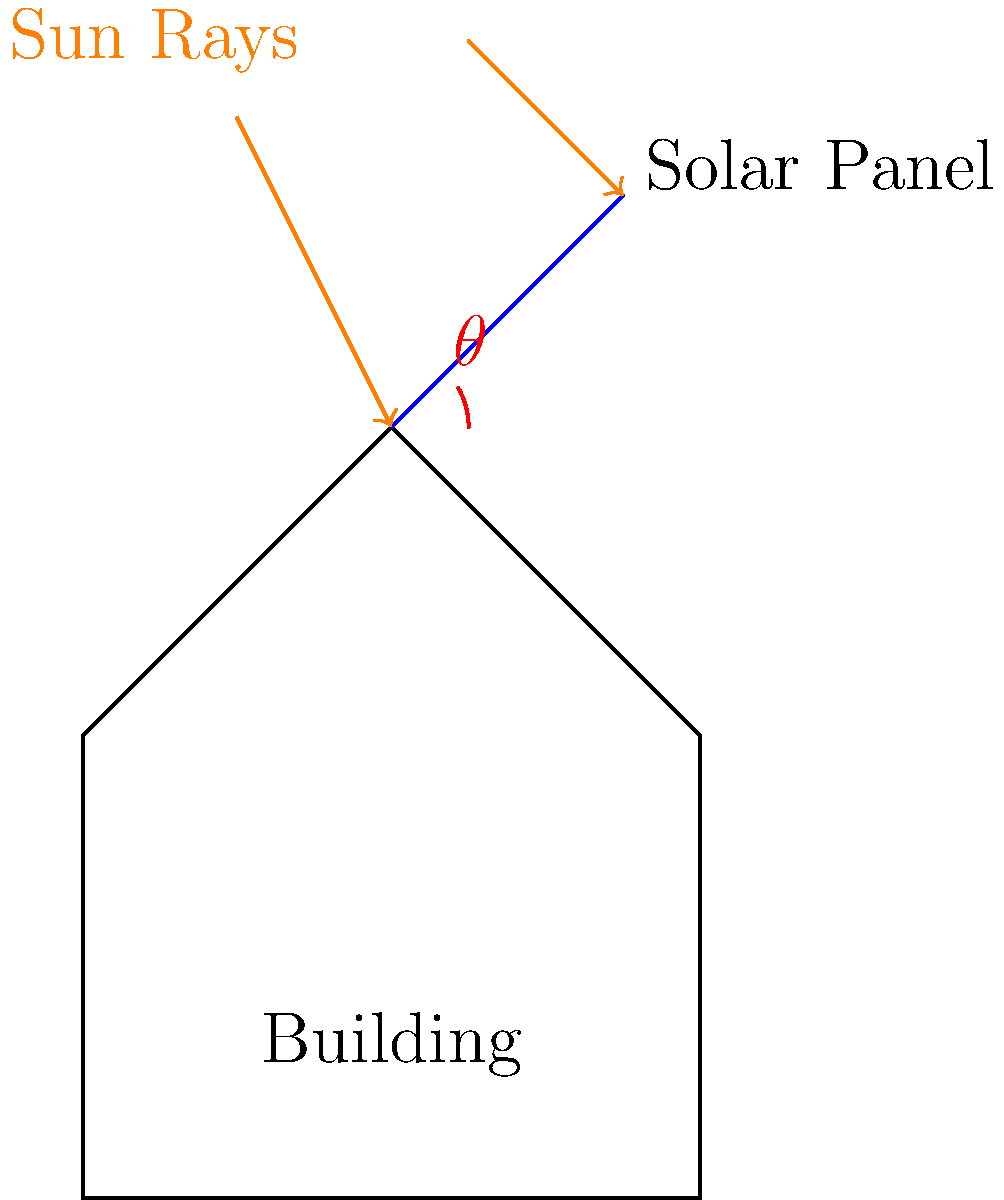As a budget-conscious fashion enthusiast interested in sustainable building design, you're researching solar panel installations. What is the optimal angle $\theta$ for mounting solar panels on a building roof in a location with a latitude of 30°N to maximize energy capture while minimizing installation costs? To determine the optimal angle for solar panels, we need to consider the following factors:

1. Solar panel efficiency is highest when sunlight hits the panel at a perpendicular angle.
2. The sun's position changes throughout the year, but we want to maximize annual energy production.
3. A general rule of thumb for fixed solar panels is to set the tilt angle equal to the latitude of the location.

Step 1: Identify the latitude of the location
The given latitude is 30°N.

Step 2: Apply the rule of thumb
Optimal tilt angle ≈ Latitude
$\theta \approx 30°$

Step 3: Consider cost-effectiveness
While slight adjustments to this angle might yield marginal improvements in energy capture, they often come with increased installation costs. For a budget-conscious approach, sticking to the simple latitude rule is most cost-effective.

Step 4: Account for local factors
In practice, local factors such as weather patterns, shading, and roof pitch might necessitate small adjustments. However, without specific local data, the latitude rule remains the best general guideline.

Therefore, for a location at 30°N latitude, the optimal angle for mounting solar panels on a building roof, balancing energy capture and installation costs, is approximately 30°.
Answer: 30° 